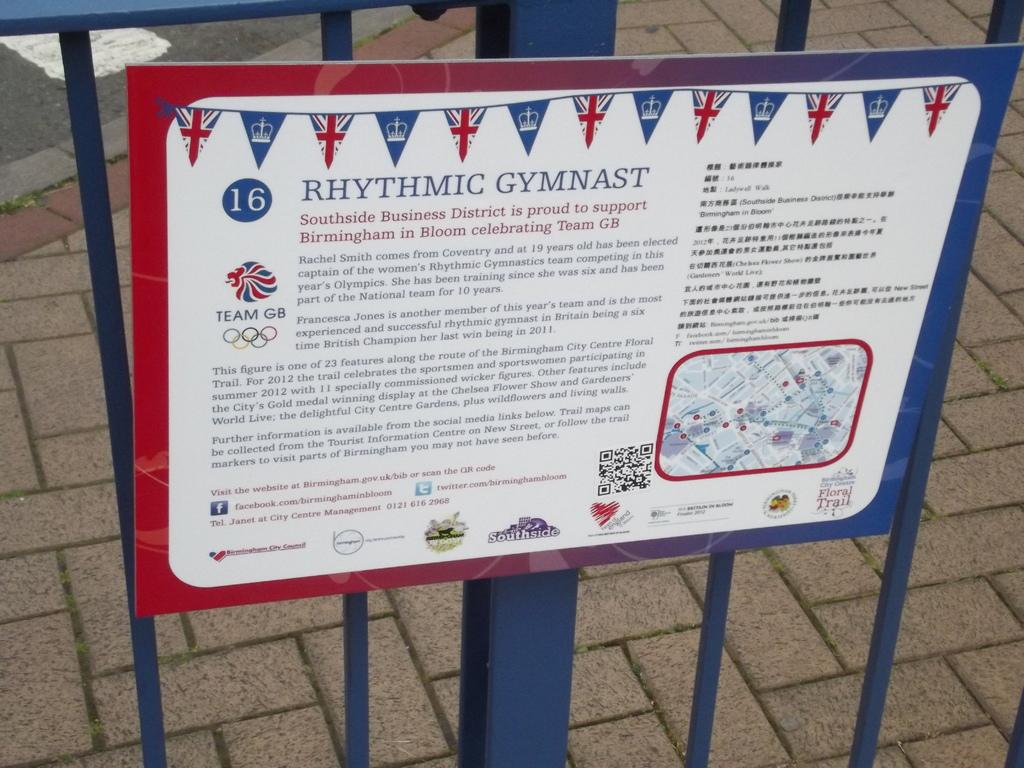<image>
Describe the image concisely. A sign hangs against a metal fence that reads Rhythmic Gymnast 